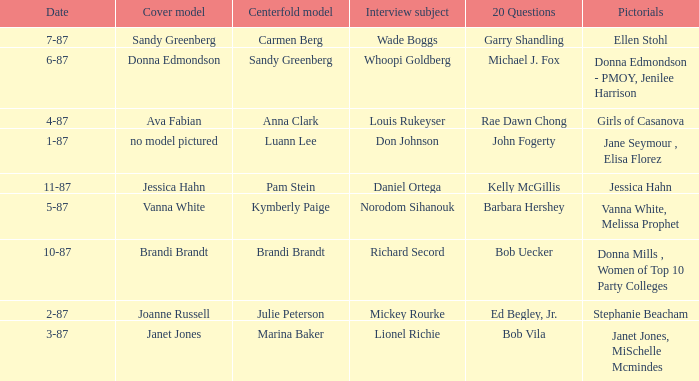When was the Kymberly Paige the Centerfold? 5-87. 